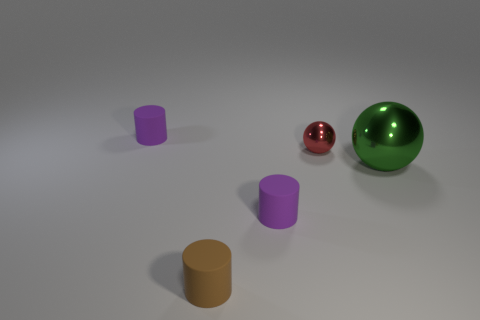There is a cylinder behind the metallic sphere that is on the right side of the shiny object behind the big shiny thing; what is its material?
Make the answer very short. Rubber. What number of other things are there of the same size as the brown thing?
Ensure brevity in your answer.  3. The large metal sphere has what color?
Make the answer very short. Green. What color is the small metal object that is in front of the tiny purple cylinder behind the small red thing?
Your response must be concise. Red. There is a thing that is in front of the small purple matte thing in front of the big green shiny object; what number of tiny red things are in front of it?
Provide a short and direct response. 0. Are there any purple matte things behind the tiny red shiny object?
Keep it short and to the point. Yes. Is there anything else that is the same color as the small ball?
Offer a terse response. No. How many blocks are either brown rubber objects or purple objects?
Give a very brief answer. 0. What number of rubber things are both in front of the small red sphere and behind the tiny brown cylinder?
Your answer should be very brief. 1. Are there the same number of tiny cylinders that are to the left of the red sphere and cylinders in front of the brown cylinder?
Offer a terse response. No. 